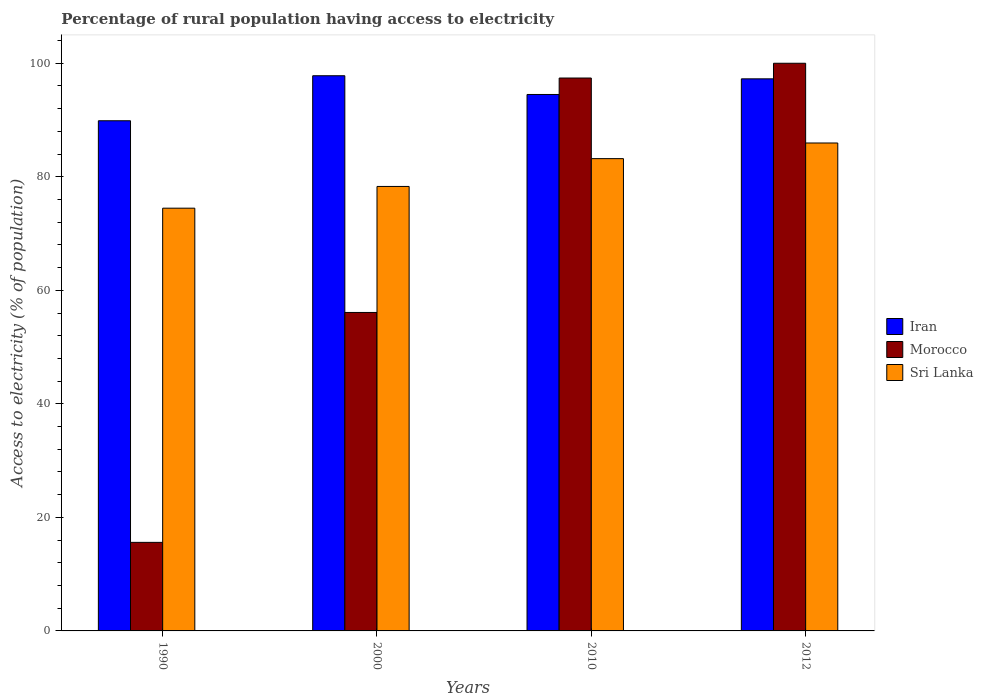How many different coloured bars are there?
Your answer should be compact. 3. Are the number of bars on each tick of the X-axis equal?
Your response must be concise. Yes. How many bars are there on the 4th tick from the right?
Give a very brief answer. 3. In how many cases, is the number of bars for a given year not equal to the number of legend labels?
Offer a very short reply. 0. What is the percentage of rural population having access to electricity in Sri Lanka in 2000?
Provide a short and direct response. 78.3. Across all years, what is the maximum percentage of rural population having access to electricity in Sri Lanka?
Give a very brief answer. 85.95. Across all years, what is the minimum percentage of rural population having access to electricity in Sri Lanka?
Provide a succinct answer. 74.47. What is the total percentage of rural population having access to electricity in Iran in the graph?
Your answer should be compact. 379.42. What is the difference between the percentage of rural population having access to electricity in Iran in 2010 and that in 2012?
Your answer should be very brief. -2.75. What is the difference between the percentage of rural population having access to electricity in Morocco in 2012 and the percentage of rural population having access to electricity in Iran in 1990?
Make the answer very short. 10.13. What is the average percentage of rural population having access to electricity in Sri Lanka per year?
Provide a succinct answer. 80.48. In the year 1990, what is the difference between the percentage of rural population having access to electricity in Sri Lanka and percentage of rural population having access to electricity in Iran?
Your answer should be very brief. -15.4. In how many years, is the percentage of rural population having access to electricity in Morocco greater than 12 %?
Offer a terse response. 4. What is the ratio of the percentage of rural population having access to electricity in Iran in 2010 to that in 2012?
Keep it short and to the point. 0.97. What is the difference between the highest and the second highest percentage of rural population having access to electricity in Morocco?
Make the answer very short. 2.6. What is the difference between the highest and the lowest percentage of rural population having access to electricity in Iran?
Your answer should be compact. 7.93. In how many years, is the percentage of rural population having access to electricity in Iran greater than the average percentage of rural population having access to electricity in Iran taken over all years?
Provide a succinct answer. 2. Is the sum of the percentage of rural population having access to electricity in Sri Lanka in 2000 and 2012 greater than the maximum percentage of rural population having access to electricity in Iran across all years?
Provide a succinct answer. Yes. What does the 1st bar from the left in 2000 represents?
Provide a short and direct response. Iran. What does the 1st bar from the right in 2010 represents?
Your answer should be compact. Sri Lanka. How many bars are there?
Your answer should be compact. 12. Are all the bars in the graph horizontal?
Offer a terse response. No. How many years are there in the graph?
Provide a succinct answer. 4. What is the difference between two consecutive major ticks on the Y-axis?
Offer a terse response. 20. Are the values on the major ticks of Y-axis written in scientific E-notation?
Your answer should be compact. No. Where does the legend appear in the graph?
Your response must be concise. Center right. How are the legend labels stacked?
Make the answer very short. Vertical. What is the title of the graph?
Keep it short and to the point. Percentage of rural population having access to electricity. What is the label or title of the X-axis?
Your response must be concise. Years. What is the label or title of the Y-axis?
Provide a succinct answer. Access to electricity (% of population). What is the Access to electricity (% of population) of Iran in 1990?
Make the answer very short. 89.87. What is the Access to electricity (% of population) of Sri Lanka in 1990?
Your response must be concise. 74.47. What is the Access to electricity (% of population) in Iran in 2000?
Ensure brevity in your answer.  97.8. What is the Access to electricity (% of population) of Morocco in 2000?
Your answer should be compact. 56.1. What is the Access to electricity (% of population) in Sri Lanka in 2000?
Provide a short and direct response. 78.3. What is the Access to electricity (% of population) in Iran in 2010?
Offer a very short reply. 94.5. What is the Access to electricity (% of population) of Morocco in 2010?
Your answer should be very brief. 97.4. What is the Access to electricity (% of population) in Sri Lanka in 2010?
Offer a terse response. 83.2. What is the Access to electricity (% of population) in Iran in 2012?
Give a very brief answer. 97.25. What is the Access to electricity (% of population) in Morocco in 2012?
Your answer should be very brief. 100. What is the Access to electricity (% of population) in Sri Lanka in 2012?
Keep it short and to the point. 85.95. Across all years, what is the maximum Access to electricity (% of population) of Iran?
Ensure brevity in your answer.  97.8. Across all years, what is the maximum Access to electricity (% of population) of Sri Lanka?
Give a very brief answer. 85.95. Across all years, what is the minimum Access to electricity (% of population) in Iran?
Your response must be concise. 89.87. Across all years, what is the minimum Access to electricity (% of population) of Morocco?
Your answer should be very brief. 15.6. Across all years, what is the minimum Access to electricity (% of population) in Sri Lanka?
Your response must be concise. 74.47. What is the total Access to electricity (% of population) in Iran in the graph?
Offer a terse response. 379.42. What is the total Access to electricity (% of population) in Morocco in the graph?
Provide a succinct answer. 269.1. What is the total Access to electricity (% of population) in Sri Lanka in the graph?
Your answer should be very brief. 321.92. What is the difference between the Access to electricity (% of population) of Iran in 1990 and that in 2000?
Offer a terse response. -7.93. What is the difference between the Access to electricity (% of population) in Morocco in 1990 and that in 2000?
Your response must be concise. -40.5. What is the difference between the Access to electricity (% of population) in Sri Lanka in 1990 and that in 2000?
Your answer should be very brief. -3.83. What is the difference between the Access to electricity (% of population) in Iran in 1990 and that in 2010?
Provide a short and direct response. -4.63. What is the difference between the Access to electricity (% of population) in Morocco in 1990 and that in 2010?
Ensure brevity in your answer.  -81.8. What is the difference between the Access to electricity (% of population) of Sri Lanka in 1990 and that in 2010?
Your response must be concise. -8.73. What is the difference between the Access to electricity (% of population) in Iran in 1990 and that in 2012?
Provide a succinct answer. -7.38. What is the difference between the Access to electricity (% of population) in Morocco in 1990 and that in 2012?
Give a very brief answer. -84.4. What is the difference between the Access to electricity (% of population) of Sri Lanka in 1990 and that in 2012?
Offer a terse response. -11.48. What is the difference between the Access to electricity (% of population) in Iran in 2000 and that in 2010?
Ensure brevity in your answer.  3.3. What is the difference between the Access to electricity (% of population) of Morocco in 2000 and that in 2010?
Your answer should be compact. -41.3. What is the difference between the Access to electricity (% of population) of Sri Lanka in 2000 and that in 2010?
Your answer should be very brief. -4.9. What is the difference between the Access to electricity (% of population) of Iran in 2000 and that in 2012?
Make the answer very short. 0.55. What is the difference between the Access to electricity (% of population) of Morocco in 2000 and that in 2012?
Your answer should be very brief. -43.9. What is the difference between the Access to electricity (% of population) of Sri Lanka in 2000 and that in 2012?
Keep it short and to the point. -7.65. What is the difference between the Access to electricity (% of population) in Iran in 2010 and that in 2012?
Provide a short and direct response. -2.75. What is the difference between the Access to electricity (% of population) of Morocco in 2010 and that in 2012?
Your answer should be compact. -2.6. What is the difference between the Access to electricity (% of population) in Sri Lanka in 2010 and that in 2012?
Make the answer very short. -2.75. What is the difference between the Access to electricity (% of population) of Iran in 1990 and the Access to electricity (% of population) of Morocco in 2000?
Your response must be concise. 33.77. What is the difference between the Access to electricity (% of population) in Iran in 1990 and the Access to electricity (% of population) in Sri Lanka in 2000?
Make the answer very short. 11.57. What is the difference between the Access to electricity (% of population) of Morocco in 1990 and the Access to electricity (% of population) of Sri Lanka in 2000?
Offer a very short reply. -62.7. What is the difference between the Access to electricity (% of population) in Iran in 1990 and the Access to electricity (% of population) in Morocco in 2010?
Provide a succinct answer. -7.53. What is the difference between the Access to electricity (% of population) of Iran in 1990 and the Access to electricity (% of population) of Sri Lanka in 2010?
Give a very brief answer. 6.67. What is the difference between the Access to electricity (% of population) in Morocco in 1990 and the Access to electricity (% of population) in Sri Lanka in 2010?
Provide a short and direct response. -67.6. What is the difference between the Access to electricity (% of population) of Iran in 1990 and the Access to electricity (% of population) of Morocco in 2012?
Give a very brief answer. -10.13. What is the difference between the Access to electricity (% of population) of Iran in 1990 and the Access to electricity (% of population) of Sri Lanka in 2012?
Keep it short and to the point. 3.92. What is the difference between the Access to electricity (% of population) in Morocco in 1990 and the Access to electricity (% of population) in Sri Lanka in 2012?
Offer a very short reply. -70.35. What is the difference between the Access to electricity (% of population) in Morocco in 2000 and the Access to electricity (% of population) in Sri Lanka in 2010?
Your response must be concise. -27.1. What is the difference between the Access to electricity (% of population) of Iran in 2000 and the Access to electricity (% of population) of Sri Lanka in 2012?
Ensure brevity in your answer.  11.85. What is the difference between the Access to electricity (% of population) of Morocco in 2000 and the Access to electricity (% of population) of Sri Lanka in 2012?
Provide a short and direct response. -29.85. What is the difference between the Access to electricity (% of population) in Iran in 2010 and the Access to electricity (% of population) in Morocco in 2012?
Provide a succinct answer. -5.5. What is the difference between the Access to electricity (% of population) of Iran in 2010 and the Access to electricity (% of population) of Sri Lanka in 2012?
Ensure brevity in your answer.  8.55. What is the difference between the Access to electricity (% of population) of Morocco in 2010 and the Access to electricity (% of population) of Sri Lanka in 2012?
Your answer should be compact. 11.45. What is the average Access to electricity (% of population) in Iran per year?
Offer a terse response. 94.86. What is the average Access to electricity (% of population) in Morocco per year?
Provide a short and direct response. 67.28. What is the average Access to electricity (% of population) of Sri Lanka per year?
Provide a short and direct response. 80.48. In the year 1990, what is the difference between the Access to electricity (% of population) of Iran and Access to electricity (% of population) of Morocco?
Provide a short and direct response. 74.27. In the year 1990, what is the difference between the Access to electricity (% of population) in Morocco and Access to electricity (% of population) in Sri Lanka?
Ensure brevity in your answer.  -58.87. In the year 2000, what is the difference between the Access to electricity (% of population) of Iran and Access to electricity (% of population) of Morocco?
Offer a terse response. 41.7. In the year 2000, what is the difference between the Access to electricity (% of population) of Iran and Access to electricity (% of population) of Sri Lanka?
Keep it short and to the point. 19.5. In the year 2000, what is the difference between the Access to electricity (% of population) in Morocco and Access to electricity (% of population) in Sri Lanka?
Your answer should be very brief. -22.2. In the year 2010, what is the difference between the Access to electricity (% of population) of Iran and Access to electricity (% of population) of Morocco?
Offer a very short reply. -2.9. In the year 2012, what is the difference between the Access to electricity (% of population) of Iran and Access to electricity (% of population) of Morocco?
Make the answer very short. -2.75. In the year 2012, what is the difference between the Access to electricity (% of population) in Iran and Access to electricity (% of population) in Sri Lanka?
Ensure brevity in your answer.  11.3. In the year 2012, what is the difference between the Access to electricity (% of population) of Morocco and Access to electricity (% of population) of Sri Lanka?
Provide a short and direct response. 14.05. What is the ratio of the Access to electricity (% of population) in Iran in 1990 to that in 2000?
Keep it short and to the point. 0.92. What is the ratio of the Access to electricity (% of population) of Morocco in 1990 to that in 2000?
Keep it short and to the point. 0.28. What is the ratio of the Access to electricity (% of population) of Sri Lanka in 1990 to that in 2000?
Give a very brief answer. 0.95. What is the ratio of the Access to electricity (% of population) of Iran in 1990 to that in 2010?
Your response must be concise. 0.95. What is the ratio of the Access to electricity (% of population) in Morocco in 1990 to that in 2010?
Your answer should be compact. 0.16. What is the ratio of the Access to electricity (% of population) in Sri Lanka in 1990 to that in 2010?
Offer a terse response. 0.9. What is the ratio of the Access to electricity (% of population) of Iran in 1990 to that in 2012?
Provide a short and direct response. 0.92. What is the ratio of the Access to electricity (% of population) of Morocco in 1990 to that in 2012?
Your response must be concise. 0.16. What is the ratio of the Access to electricity (% of population) of Sri Lanka in 1990 to that in 2012?
Keep it short and to the point. 0.87. What is the ratio of the Access to electricity (% of population) of Iran in 2000 to that in 2010?
Offer a very short reply. 1.03. What is the ratio of the Access to electricity (% of population) in Morocco in 2000 to that in 2010?
Your answer should be compact. 0.58. What is the ratio of the Access to electricity (% of population) of Sri Lanka in 2000 to that in 2010?
Keep it short and to the point. 0.94. What is the ratio of the Access to electricity (% of population) of Iran in 2000 to that in 2012?
Make the answer very short. 1.01. What is the ratio of the Access to electricity (% of population) in Morocco in 2000 to that in 2012?
Your answer should be compact. 0.56. What is the ratio of the Access to electricity (% of population) of Sri Lanka in 2000 to that in 2012?
Your answer should be compact. 0.91. What is the ratio of the Access to electricity (% of population) in Iran in 2010 to that in 2012?
Make the answer very short. 0.97. What is the difference between the highest and the second highest Access to electricity (% of population) of Iran?
Your answer should be compact. 0.55. What is the difference between the highest and the second highest Access to electricity (% of population) of Morocco?
Make the answer very short. 2.6. What is the difference between the highest and the second highest Access to electricity (% of population) in Sri Lanka?
Provide a succinct answer. 2.75. What is the difference between the highest and the lowest Access to electricity (% of population) in Iran?
Keep it short and to the point. 7.93. What is the difference between the highest and the lowest Access to electricity (% of population) of Morocco?
Offer a very short reply. 84.4. What is the difference between the highest and the lowest Access to electricity (% of population) in Sri Lanka?
Offer a terse response. 11.48. 